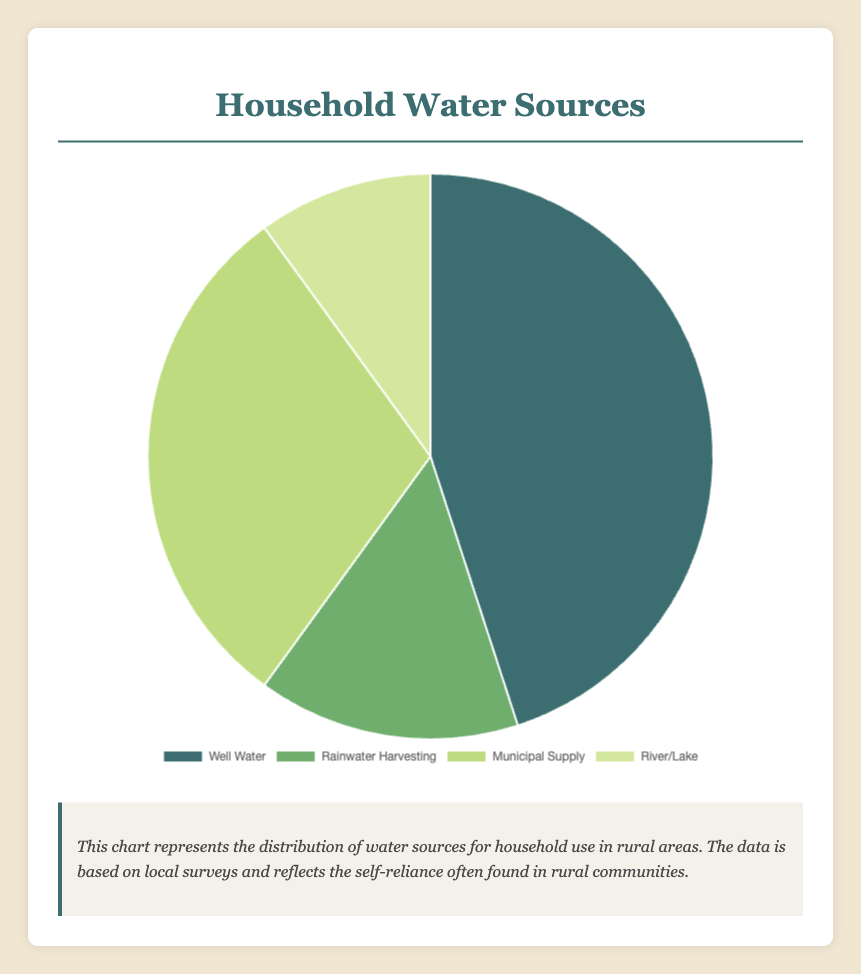What percentage of household water is sourced from well water? Referring to the pie chart, find the segment labeled "Well Water" and identify its percentage from the legend or directly from the pie slice.
Answer: 45% Which water source has the smallest share in the pie chart? Look at the size of each pie slice and read the labels. The smallest slice in the chart represents "River/Lake" water.
Answer: River/Lake What's the combined percentage of households using either municipal supply or rainwater harvesting? Find the segments for "Municipal Supply" and "Rainwater Harvesting" and add their percentages: 30% + 15%.
Answer: 45% What is the difference in percentage between households using well water and those using municipal supply? Subtract the percentage of "Municipal Supply" from "Well Water": 45% - 30%.
Answer: 15% Which is more common: using well water or rainwater harvesting? Compare the percentages for "Well Water" and "Rainwater Harvesting": 45% vs. 15%.
Answer: Well Water What color represents the municipal supply in the pie chart? Look at the pie chart legend to find the color associated with "Municipal Supply," which is a light green shade.
Answer: Light green If rainwater harvesting and river/lake sources were combined into one category, what would their total percentage be? Add the percentages of "Rainwater Harvesting" and "River/Lake": 15% + 10%.
Answer: 25% How many water sources make up more than half of the pie chart combined? Look for the water sources whose percentages add up to more than 50%. "Well Water" at 45% and "Municipal Supply" at 30% combined make 75%, which is more than half.
Answer: 2 Is the percentage of households using well water greater than the combined percentage of households using rainwater harvesting and river/lake? Compare 45% (Well Water) to the sum of "Rainwater Harvesting" and "River/Lake": 45% > 25%.
Answer: Yes What is the sum of the percentages of Rainwater Harvesting and Municipal Supply? Add the percentages of "Rainwater Harvesting" (15%) and "Municipal Supply" (30%).
Answer: 45% 